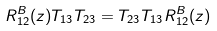Convert formula to latex. <formula><loc_0><loc_0><loc_500><loc_500>R ^ { B } _ { 1 2 } ( z ) T _ { 1 3 } T _ { 2 3 } = T _ { 2 3 } T _ { 1 3 } R ^ { B } _ { 1 2 } ( z )</formula> 